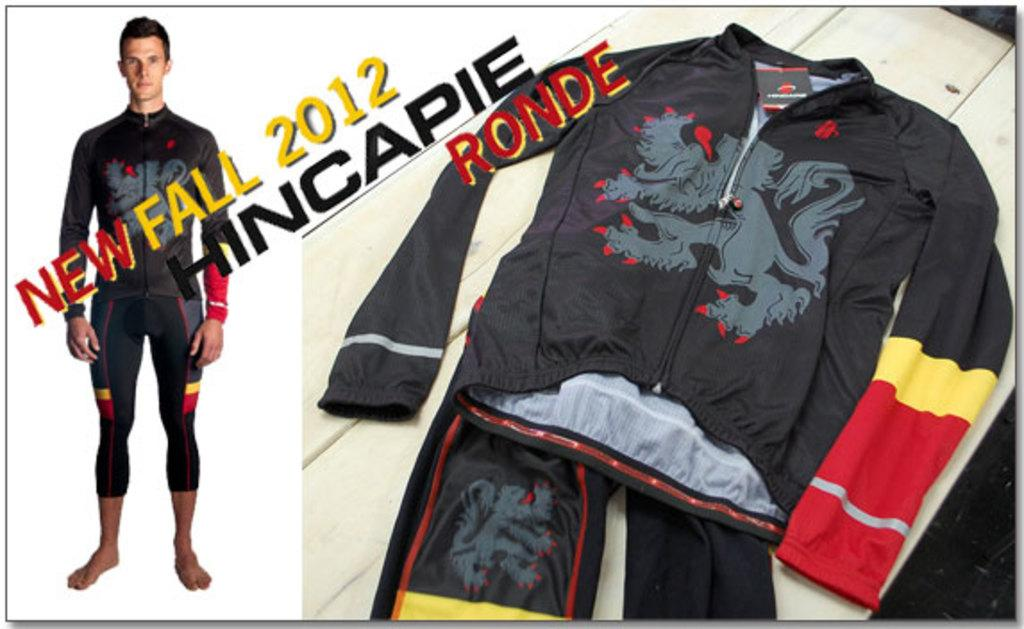Provide a one-sentence caption for the provided image. An advertisement for a mens track suit for Fall 2012. 